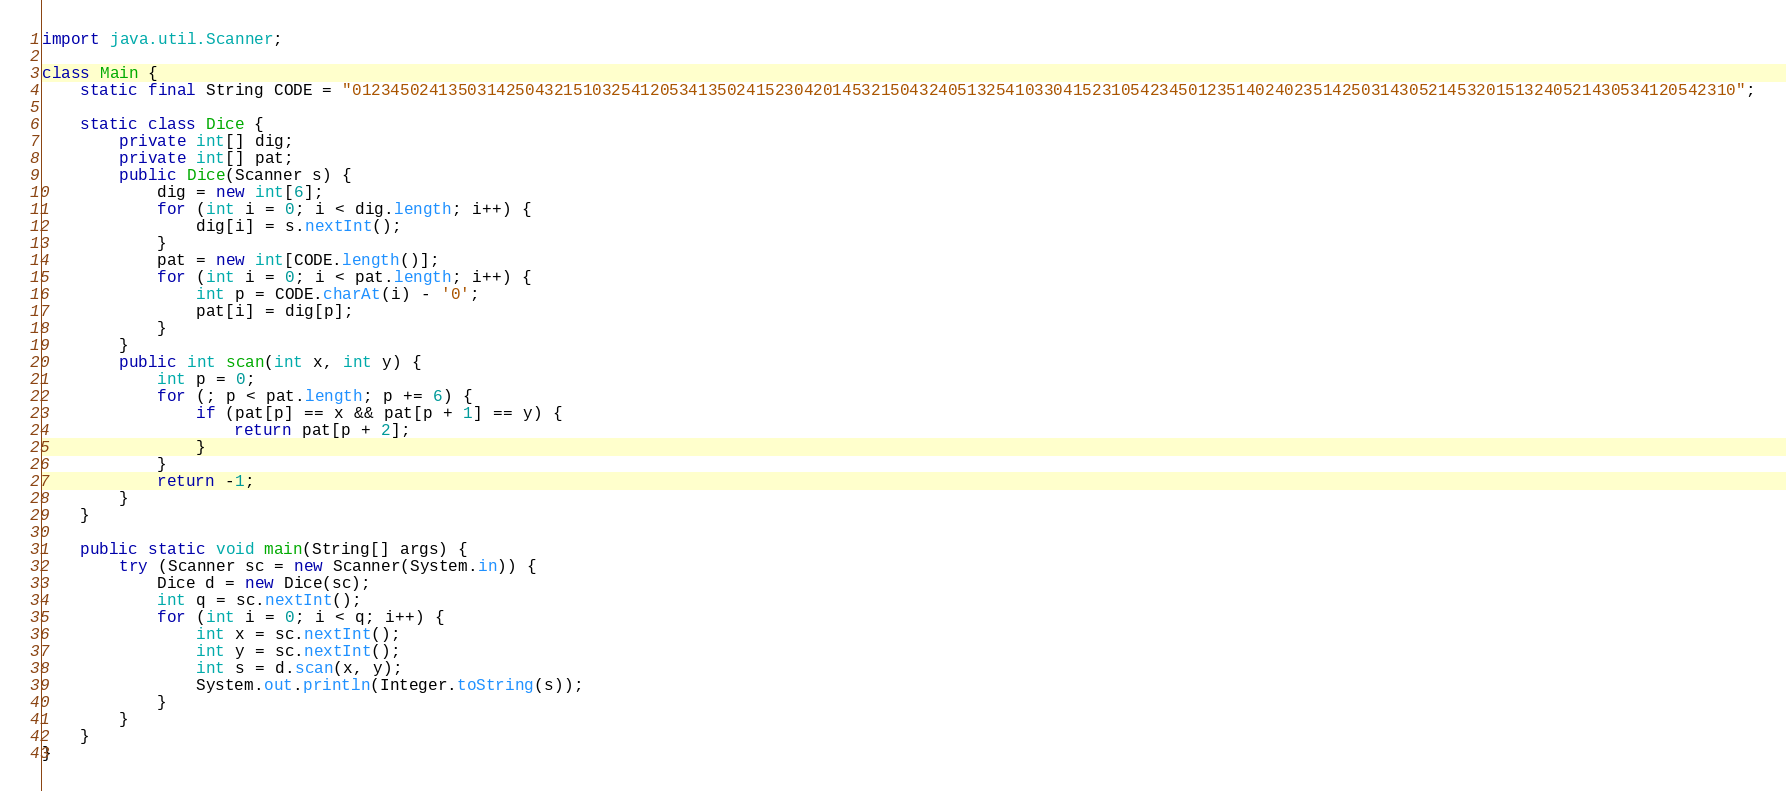Convert code to text. <code><loc_0><loc_0><loc_500><loc_500><_Java_>import java.util.Scanner;

class Main {
	static final String CODE = "012345024135031425043215103254120534135024152304201453215043240513254103304152310542345012351402402351425031430521453201513240521430534120542310";

	static class Dice {
		private int[] dig;
		private int[] pat;
		public Dice(Scanner s) {
			dig = new int[6];
			for (int i = 0; i < dig.length; i++) {
				dig[i] = s.nextInt();
			}
			pat = new int[CODE.length()];
			for (int i = 0; i < pat.length; i++) {
				int p = CODE.charAt(i) - '0';
				pat[i] = dig[p];
			}
		}
		public int scan(int x, int y) {
			int p = 0;
			for (; p < pat.length; p += 6) {
				if (pat[p] == x && pat[p + 1] == y) {
					return pat[p + 2];
				}
			}
			return -1;
		}
	}

	public static void main(String[] args) {
		try (Scanner sc = new Scanner(System.in)) {
			Dice d = new Dice(sc);
			int q = sc.nextInt();
			for (int i = 0; i < q; i++) {
				int x = sc.nextInt();
				int y = sc.nextInt();
				int s = d.scan(x, y);
				System.out.println(Integer.toString(s));
			}
		}
	}
}

</code> 